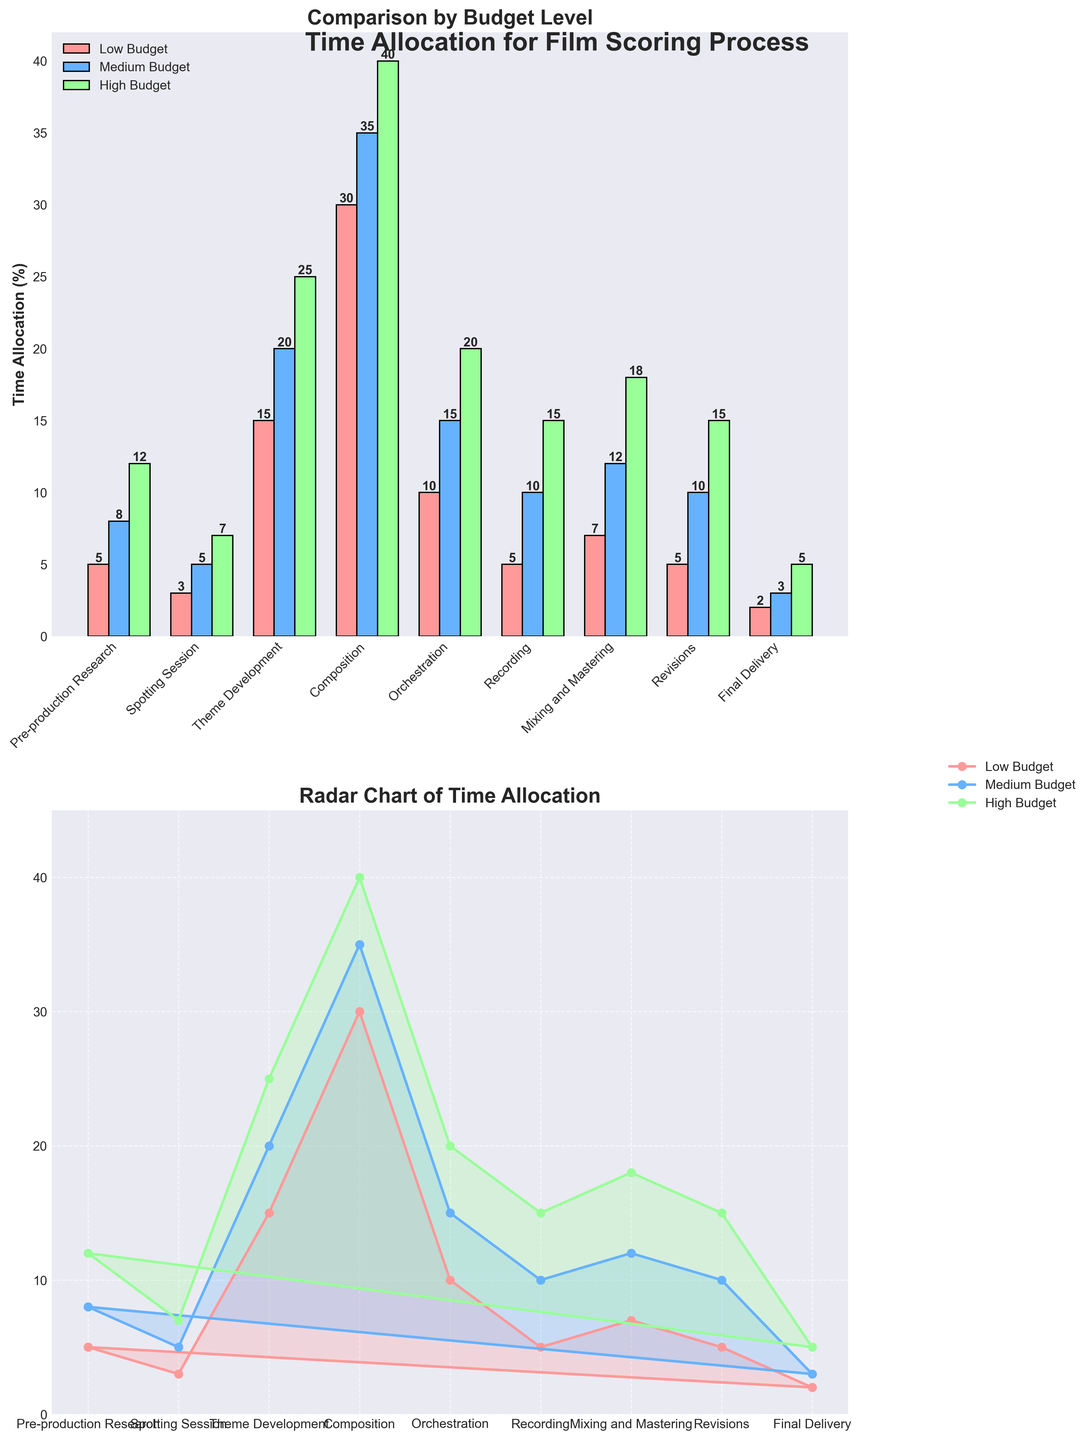What is the title of the bar plot? The title can be found at the top of the bar plot in bold, read as "Comparison by Budget Level".
Answer: Comparison by Budget Level Which budget level allocates the most time to Theme Development? In the bar plot, compare the heights of the bars for Theme Development across the three budget levels (Low, Medium, High). The High Budget has the tallest bar for Theme Development.
Answer: High Budget How much more time does Recording take in a High Budget compared to a Low Budget? Look at the Recording stage bars for both High and Low Budget. Recording in High Budget is 15% and in Low Budget is 5%. The difference is 15% - 5% = 10%.
Answer: 10% Which stage has the smallest difference in time allocation between Low Budget and Medium Budget? Calculate the difference in time allocation for each stage between Low and Medium Budget. Pre-production Research: 8-5=3; Spotting Session: 5-3=2; Theme Development: 20-15=5; Composition: 35-30=5; Orchestration: 15-10=5; Recording: 10-5=5; Mixing and Mastering: 12-7=5; Revisions: 10-5=5; Final Delivery: 3-2=1. The smallest difference is for Final Delivery (3-2=1).
Answer: Final Delivery How is the data represented in the radar plot? The radar plot presents data with three different colored lines for Low Budget, Medium Budget, and High Budget, each connected with dots corresponding to their percentage values for each stage. The plot is filled with a semi-transparent area for better visualization.
Answer: Three colored lines and filled areas What is the angle for the Composition stage in the radar chart? The radar chart is a circular plot evenly divided by the number of stages (9). Each stage corresponds to an angle, and with 9 stages, each angle is 360°/9 = 40°. Starting from 0, Composition is the 4th stage, so its angle is 3 * 40° = 120°.
Answer: 120° Compare the total time allocation for Mixing and Mastering between Low Budget and High Budget. Mixing and Mastering is 7% for Low Budget and 18% for High Budget. Total time allocation difference is 18 - 7 = 11%.
Answer: 11% Which budget level consistently shows the highest time allocation across most stages in the radar chart? In the radar chart, observe that the High Budget line (green) consistently peaks higher than the Low and Medium Budget lines across almost all stages.
Answer: High Budget 